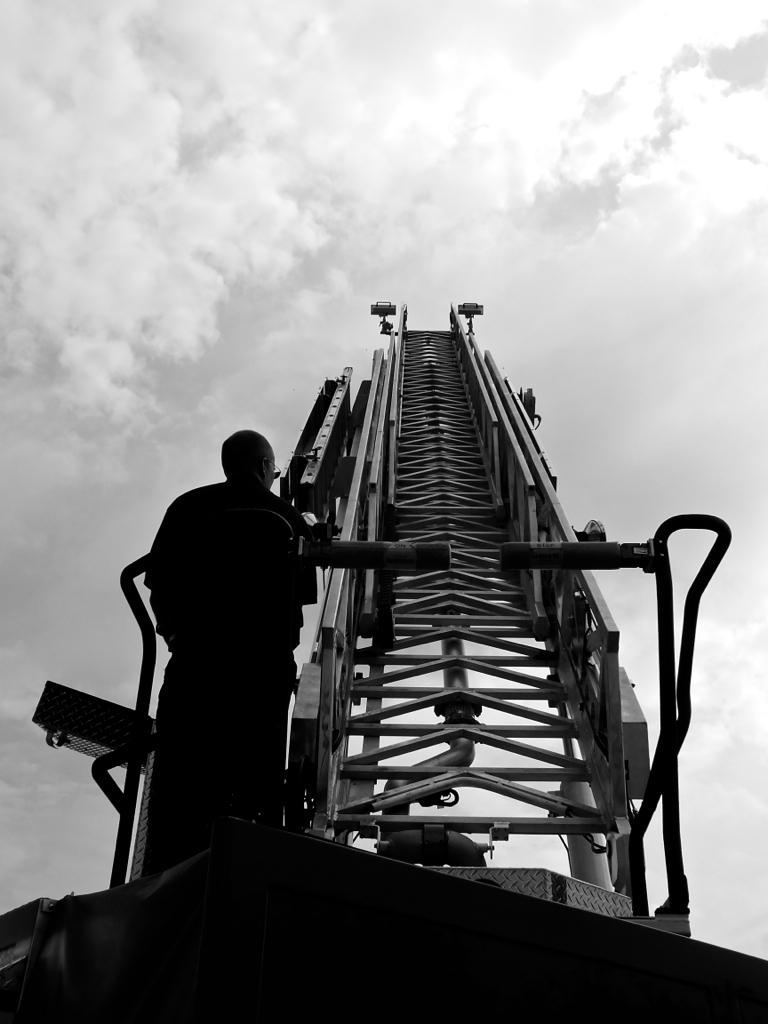What type of machinery is present in the image? There is a mobile crane in the image. Can you describe the person in the image? There is a person standing on the left side of the image. What can be seen in the background of the image? The sky is visible in the background of the image. What is the color scheme of the image? The image is black and white. How does the person in the image try to burn the mobile crane? There is no indication in the image that the person is trying to burn the mobile crane, nor is there any fire or burning depicted. 